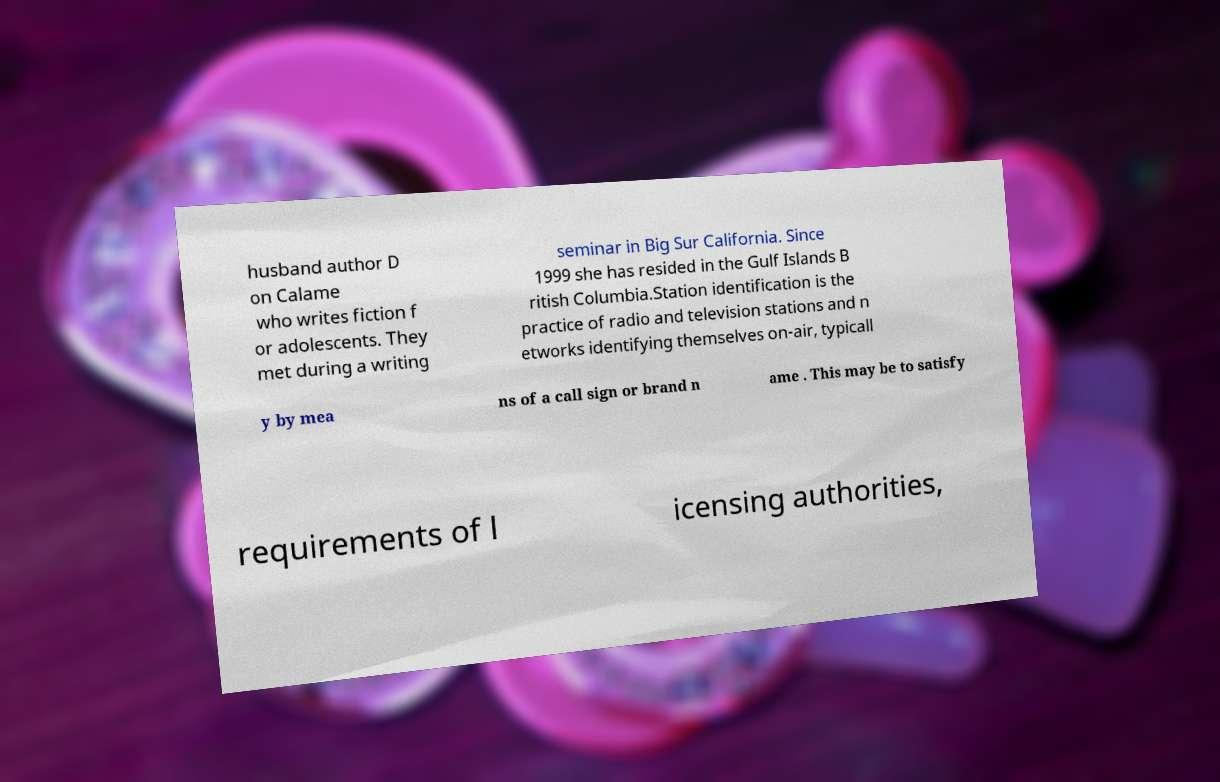Can you accurately transcribe the text from the provided image for me? husband author D on Calame who writes fiction f or adolescents. They met during a writing seminar in Big Sur California. Since 1999 she has resided in the Gulf Islands B ritish Columbia.Station identification is the practice of radio and television stations and n etworks identifying themselves on-air, typicall y by mea ns of a call sign or brand n ame . This may be to satisfy requirements of l icensing authorities, 